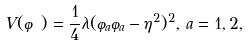Convert formula to latex. <formula><loc_0><loc_0><loc_500><loc_500>V ( \varphi ) = \frac { 1 } { 4 } \lambda ( \varphi _ { a } \varphi _ { a } - \eta ^ { 2 } ) ^ { 2 } , \, a = 1 , 2 ,</formula> 